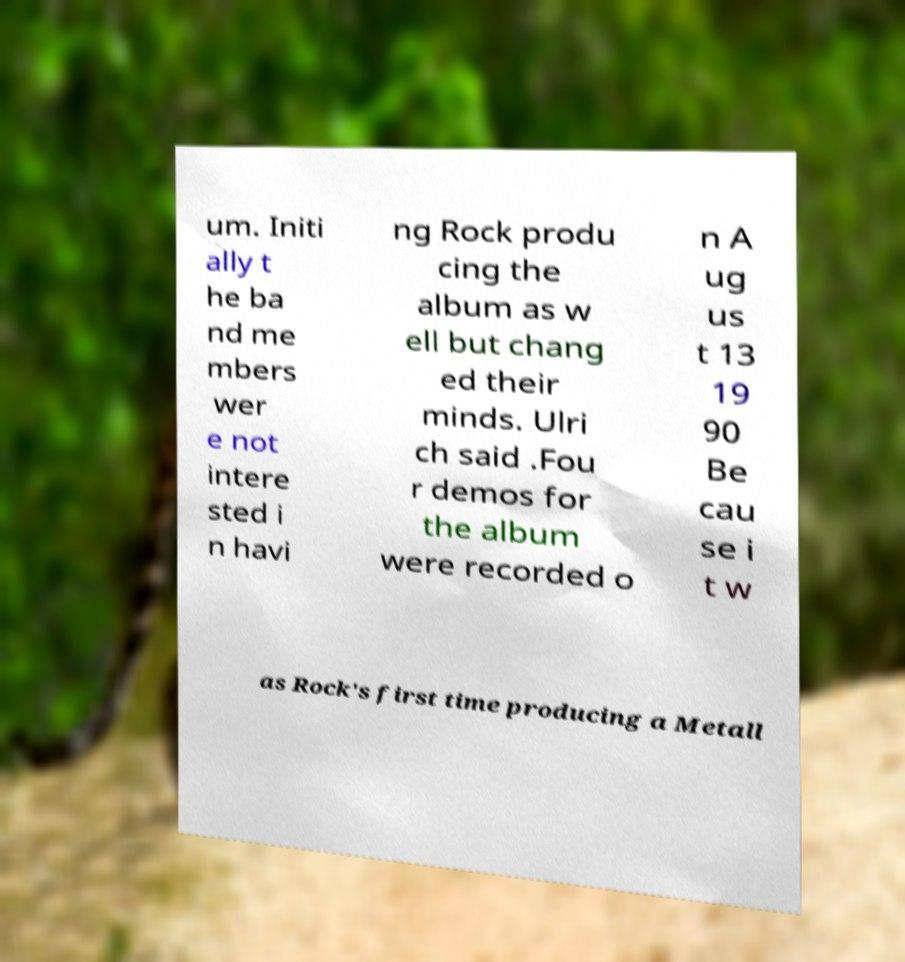Please read and relay the text visible in this image. What does it say? um. Initi ally t he ba nd me mbers wer e not intere sted i n havi ng Rock produ cing the album as w ell but chang ed their minds. Ulri ch said .Fou r demos for the album were recorded o n A ug us t 13 19 90 Be cau se i t w as Rock's first time producing a Metall 